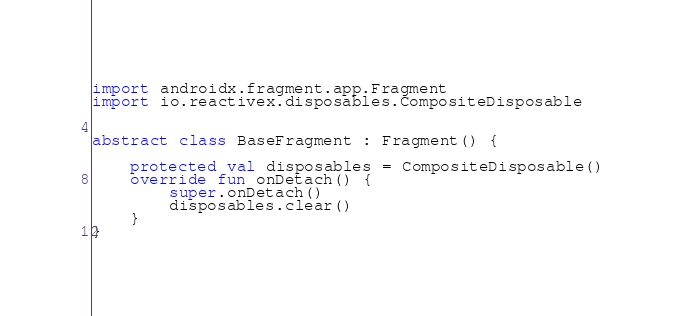<code> <loc_0><loc_0><loc_500><loc_500><_Kotlin_>
import androidx.fragment.app.Fragment
import io.reactivex.disposables.CompositeDisposable


abstract class BaseFragment : Fragment() {

    protected val disposables = CompositeDisposable()
    override fun onDetach() {
        super.onDetach()
        disposables.clear()
    }
}</code> 